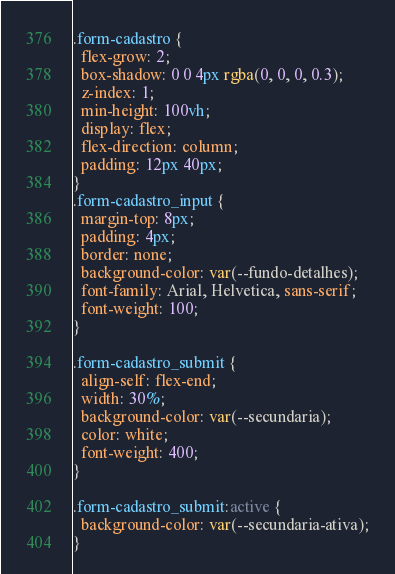Convert code to text. <code><loc_0><loc_0><loc_500><loc_500><_CSS_>.form-cadastro {
  flex-grow: 2;
  box-shadow: 0 0 4px rgba(0, 0, 0, 0.3);
  z-index: 1;
  min-height: 100vh;
  display: flex;
  flex-direction: column;
  padding: 12px 40px;
}
.form-cadastro_input {
  margin-top: 8px;
  padding: 4px;
  border: none;
  background-color: var(--fundo-detalhes);
  font-family: Arial, Helvetica, sans-serif;
  font-weight: 100;
}

.form-cadastro_submit {
  align-self: flex-end;
  width: 30%;
  background-color: var(--secundaria);
  color: white;
  font-weight: 400;
}

.form-cadastro_submit:active {
  background-color: var(--secundaria-ativa);
}
</code> 